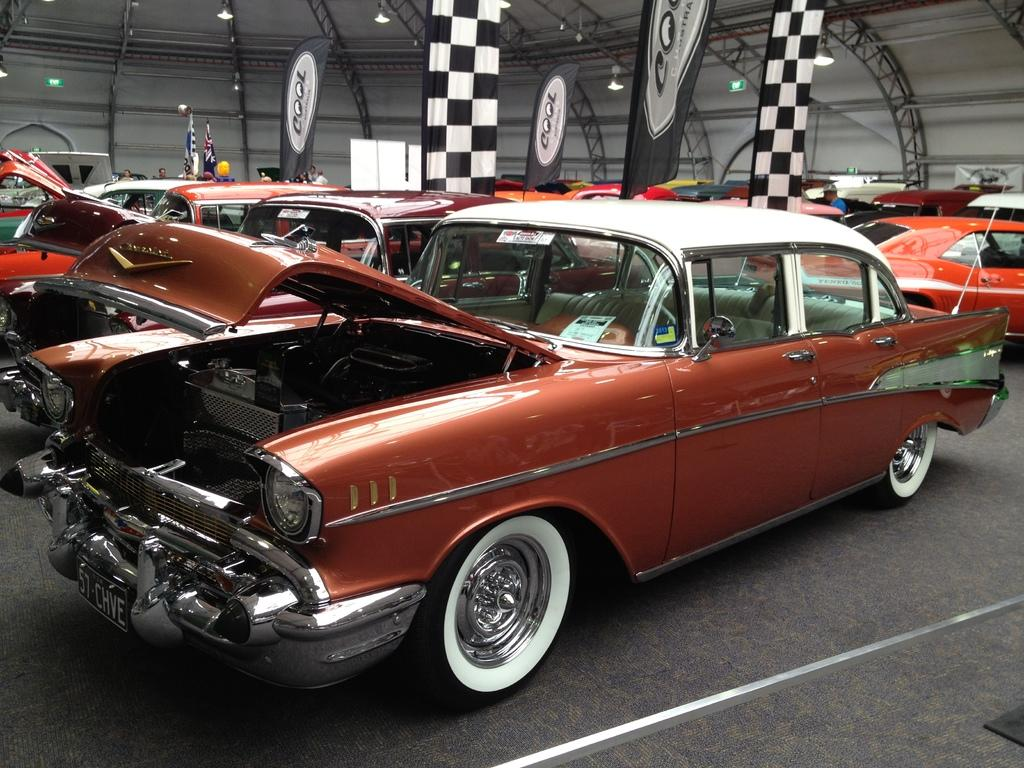What type of vehicles can be seen in the image? There are cars in the image. What else is visible in the background of the image? There are flags in the background of the image. How does the body of the car blow in the wind in the image? The body of the car does not blow in the wind in the image, as cars are not affected by wind in this manner. 